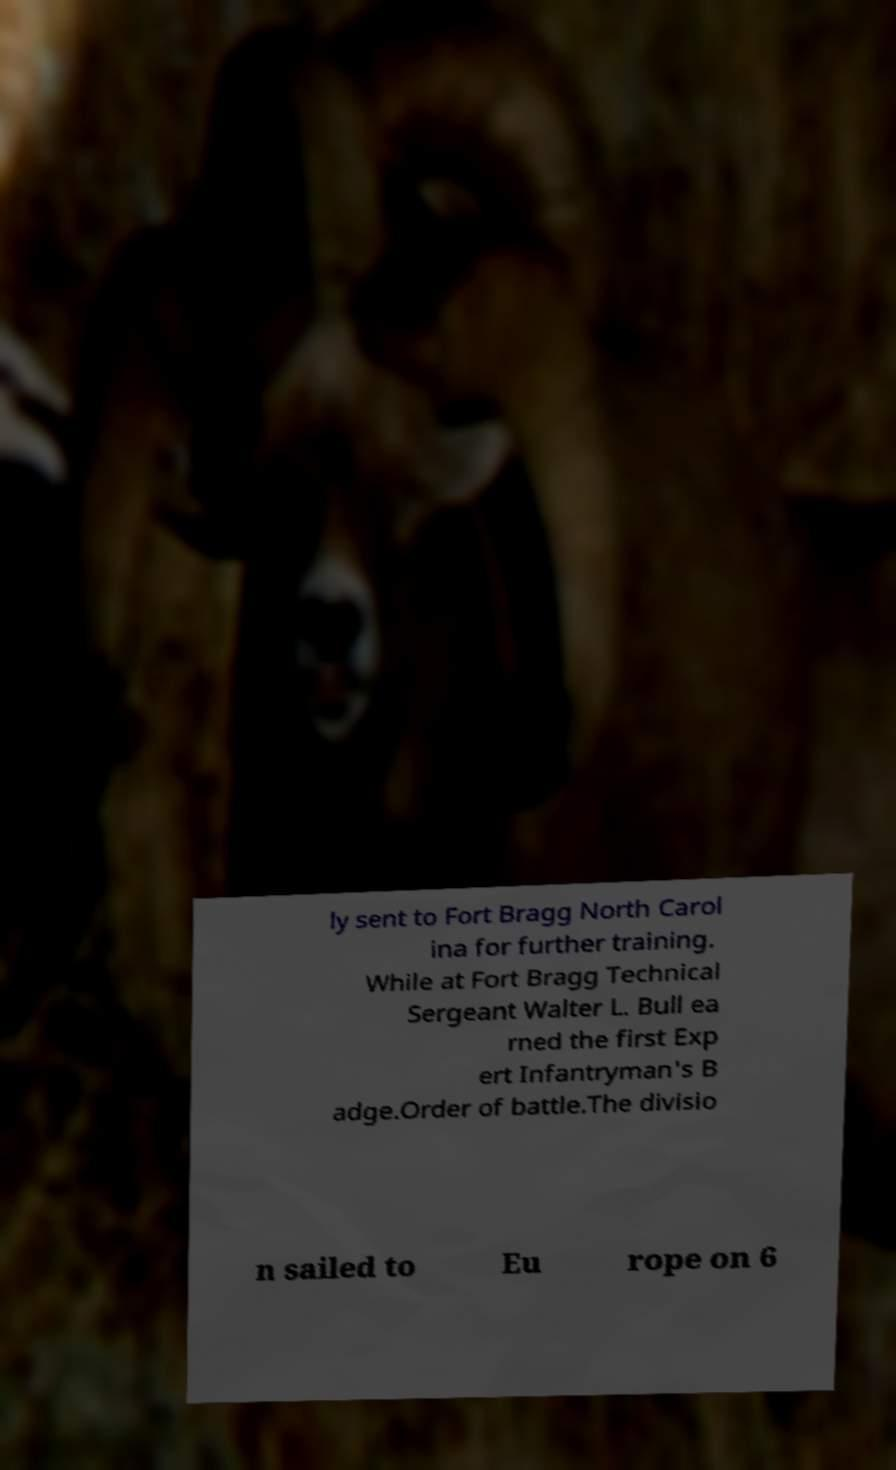What messages or text are displayed in this image? I need them in a readable, typed format. ly sent to Fort Bragg North Carol ina for further training. While at Fort Bragg Technical Sergeant Walter L. Bull ea rned the first Exp ert Infantryman's B adge.Order of battle.The divisio n sailed to Eu rope on 6 